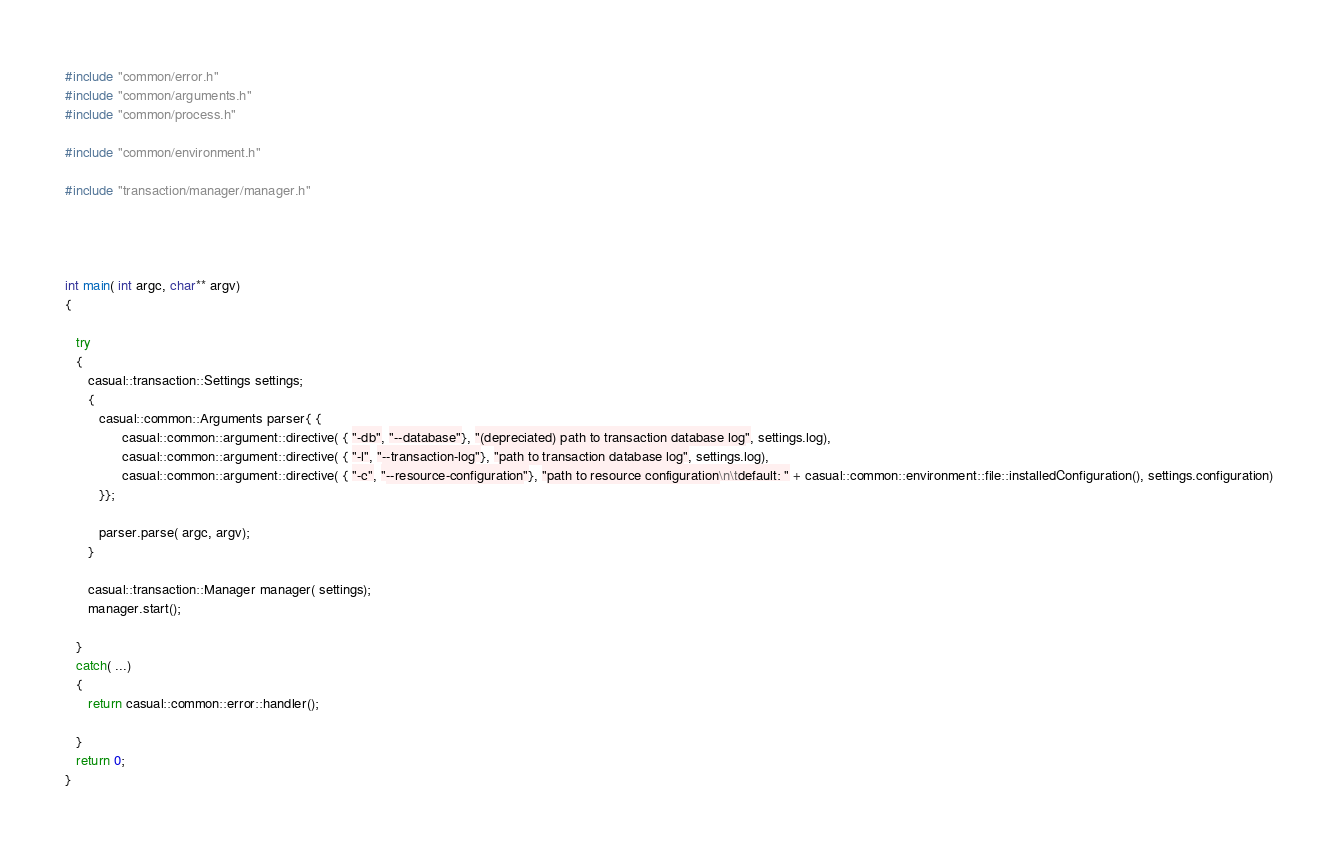<code> <loc_0><loc_0><loc_500><loc_500><_C++_>
#include "common/error.h"
#include "common/arguments.h"
#include "common/process.h"

#include "common/environment.h"

#include "transaction/manager/manager.h"




int main( int argc, char** argv)
{

   try
   {
      casual::transaction::Settings settings;
      {
         casual::common::Arguments parser{ {
               casual::common::argument::directive( { "-db", "--database"}, "(depreciated) path to transaction database log", settings.log),
               casual::common::argument::directive( { "-l", "--transaction-log"}, "path to transaction database log", settings.log),
               casual::common::argument::directive( { "-c", "--resource-configuration"}, "path to resource configuration\n\tdefault: " + casual::common::environment::file::installedConfiguration(), settings.configuration)
         }};

         parser.parse( argc, argv);
      }

      casual::transaction::Manager manager( settings);
      manager.start();

   }
   catch( ...)
   {
      return casual::common::error::handler();

   }
   return 0;
}

</code> 